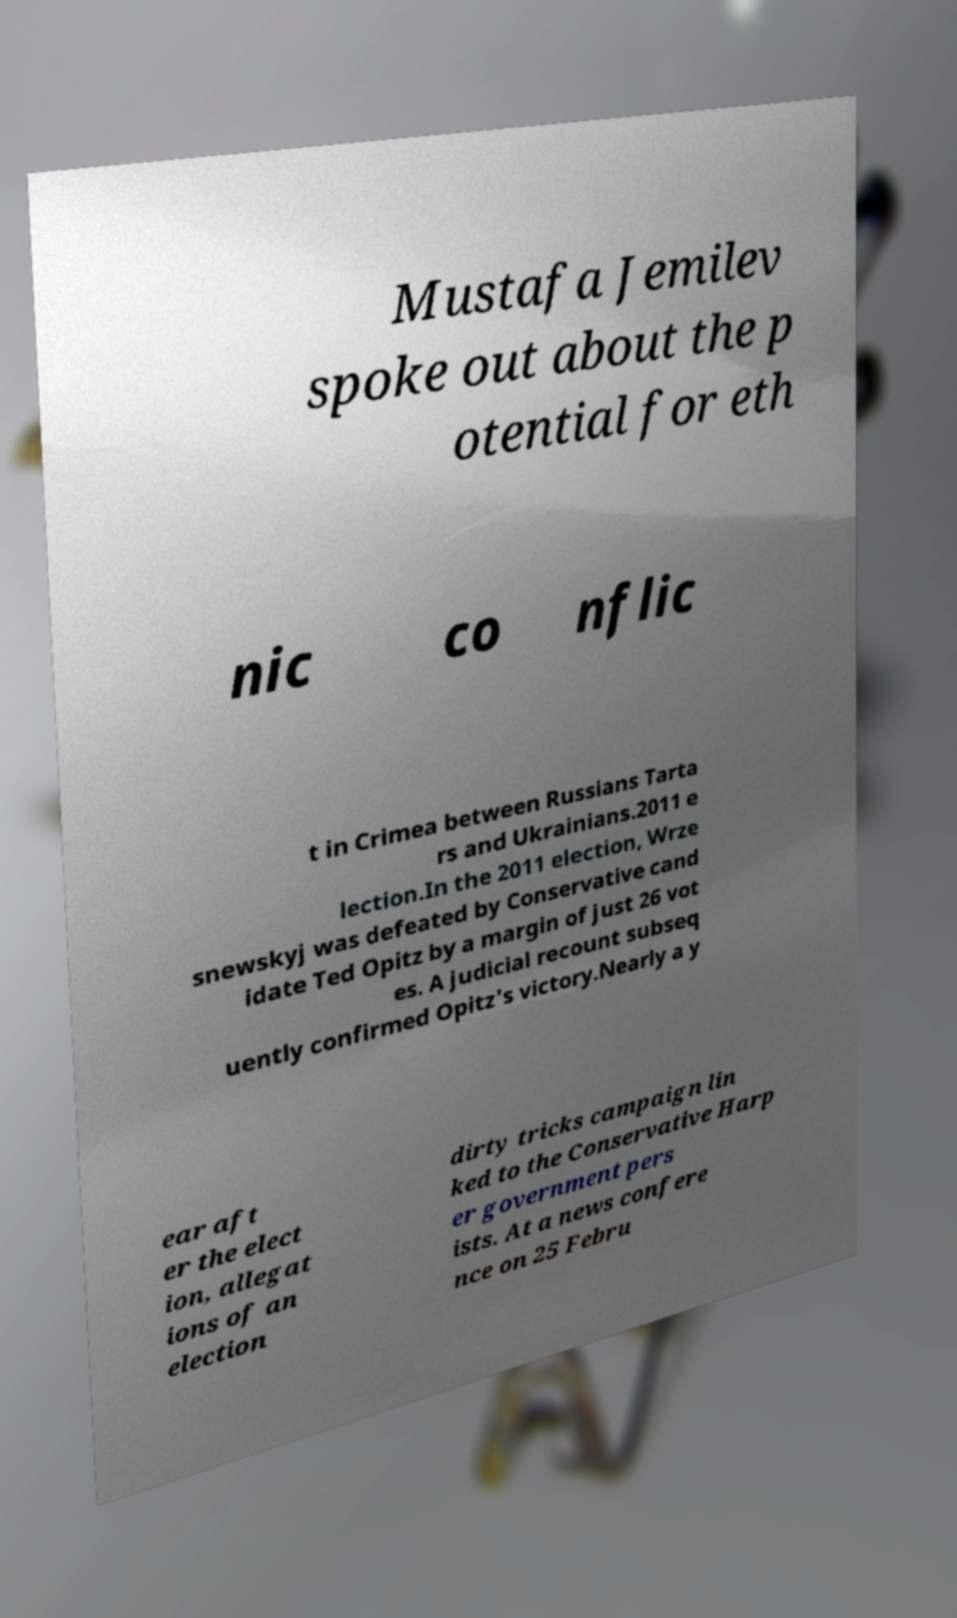Please read and relay the text visible in this image. What does it say? Mustafa Jemilev spoke out about the p otential for eth nic co nflic t in Crimea between Russians Tarta rs and Ukrainians.2011 e lection.In the 2011 election, Wrze snewskyj was defeated by Conservative cand idate Ted Opitz by a margin of just 26 vot es. A judicial recount subseq uently confirmed Opitz's victory.Nearly a y ear aft er the elect ion, allegat ions of an election dirty tricks campaign lin ked to the Conservative Harp er government pers ists. At a news confere nce on 25 Febru 